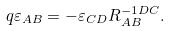Convert formula to latex. <formula><loc_0><loc_0><loc_500><loc_500>q \varepsilon _ { A B } = - \varepsilon _ { C D } R _ { A B } ^ { - 1 D C } .</formula> 